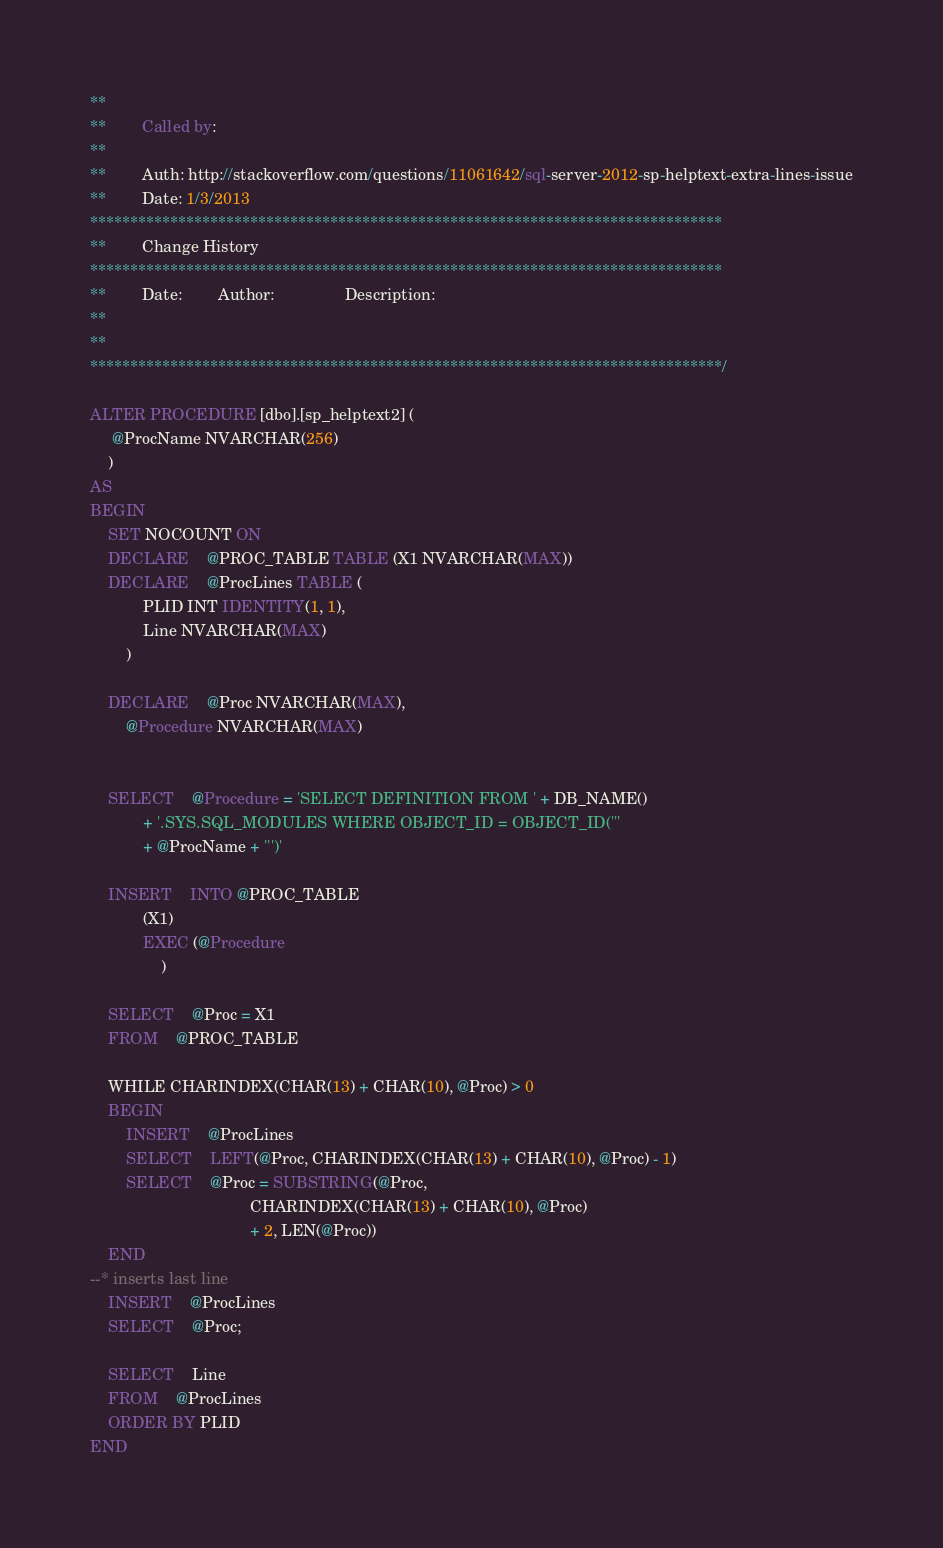Convert code to text. <code><loc_0><loc_0><loc_500><loc_500><_SQL_>**
**		Called by:
**
**		Auth: http://stackoverflow.com/questions/11061642/sql-server-2012-sp-helptext-extra-lines-issue
**		Date: 1/3/2013 
*******************************************************************************
**		Change History
*******************************************************************************
**		Date:		Author:				Description:
**		
**    
*******************************************************************************/

ALTER PROCEDURE [dbo].[sp_helptext2] (
	 @ProcName NVARCHAR(256)
	)
AS
BEGIN
	SET NOCOUNT ON
	DECLARE	@PROC_TABLE TABLE (X1 NVARCHAR(MAX))
	DECLARE	@ProcLines TABLE (
			PLID INT IDENTITY(1, 1),
			Line NVARCHAR(MAX)
		)
	
	DECLARE	@Proc NVARCHAR(MAX),
		@Procedure NVARCHAR(MAX)


	SELECT	@Procedure = 'SELECT DEFINITION FROM ' + DB_NAME()
			+ '.SYS.SQL_MODULES WHERE OBJECT_ID = OBJECT_ID('''
			+ @ProcName + ''')'

	INSERT	INTO @PROC_TABLE
			(X1)
			EXEC (@Procedure
				)

	SELECT	@Proc = X1
	FROM	@PROC_TABLE

	WHILE CHARINDEX(CHAR(13) + CHAR(10), @Proc) > 0
	BEGIN
		INSERT	@ProcLines
		SELECT	LEFT(@Proc, CHARINDEX(CHAR(13) + CHAR(10), @Proc) - 1)
		SELECT	@Proc = SUBSTRING(@Proc,
									CHARINDEX(CHAR(13) + CHAR(10), @Proc)
									+ 2, LEN(@Proc))
	END
--* inserts last line
	INSERT	@ProcLines
	SELECT	@Proc;

	SELECT	Line
	FROM	@ProcLines
	ORDER BY PLID
END

</code> 